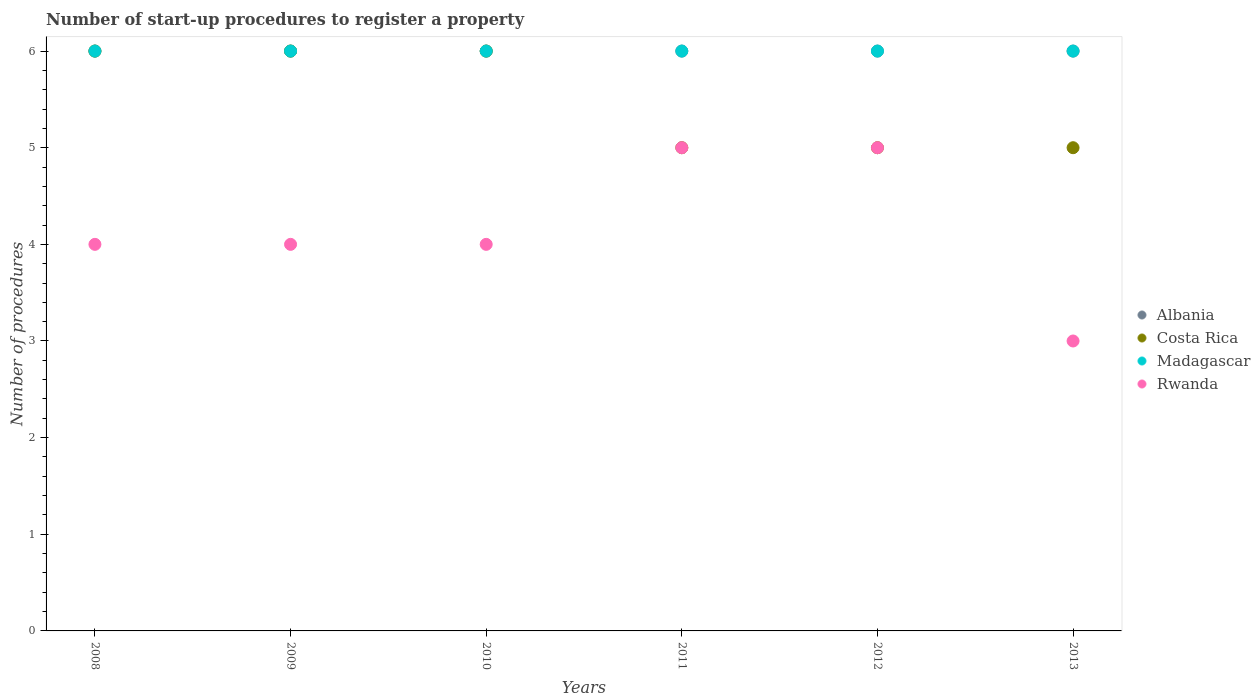How many different coloured dotlines are there?
Keep it short and to the point. 4. What is the number of procedures required to register a property in Rwanda in 2013?
Give a very brief answer. 3. Across all years, what is the maximum number of procedures required to register a property in Rwanda?
Your answer should be compact. 5. Across all years, what is the minimum number of procedures required to register a property in Rwanda?
Ensure brevity in your answer.  3. In which year was the number of procedures required to register a property in Madagascar maximum?
Offer a very short reply. 2008. In which year was the number of procedures required to register a property in Madagascar minimum?
Ensure brevity in your answer.  2008. What is the total number of procedures required to register a property in Rwanda in the graph?
Keep it short and to the point. 25. What is the difference between the number of procedures required to register a property in Costa Rica in 2010 and that in 2013?
Keep it short and to the point. 1. What is the difference between the number of procedures required to register a property in Rwanda in 2010 and the number of procedures required to register a property in Madagascar in 2012?
Provide a short and direct response. -2. In the year 2010, what is the difference between the number of procedures required to register a property in Costa Rica and number of procedures required to register a property in Albania?
Ensure brevity in your answer.  0. What is the ratio of the number of procedures required to register a property in Albania in 2011 to that in 2013?
Your answer should be very brief. 1. Is the number of procedures required to register a property in Rwanda in 2010 less than that in 2011?
Give a very brief answer. Yes. Is the sum of the number of procedures required to register a property in Madagascar in 2011 and 2012 greater than the maximum number of procedures required to register a property in Albania across all years?
Keep it short and to the point. Yes. Is it the case that in every year, the sum of the number of procedures required to register a property in Albania and number of procedures required to register a property in Rwanda  is greater than the sum of number of procedures required to register a property in Costa Rica and number of procedures required to register a property in Madagascar?
Ensure brevity in your answer.  No. Is it the case that in every year, the sum of the number of procedures required to register a property in Costa Rica and number of procedures required to register a property in Rwanda  is greater than the number of procedures required to register a property in Albania?
Make the answer very short. Yes. Does the number of procedures required to register a property in Madagascar monotonically increase over the years?
Keep it short and to the point. No. What is the difference between two consecutive major ticks on the Y-axis?
Provide a succinct answer. 1. Are the values on the major ticks of Y-axis written in scientific E-notation?
Your answer should be very brief. No. Does the graph contain any zero values?
Your answer should be very brief. No. Does the graph contain grids?
Provide a succinct answer. No. How many legend labels are there?
Your answer should be compact. 4. How are the legend labels stacked?
Make the answer very short. Vertical. What is the title of the graph?
Your answer should be compact. Number of start-up procedures to register a property. What is the label or title of the Y-axis?
Give a very brief answer. Number of procedures. What is the Number of procedures in Albania in 2008?
Make the answer very short. 6. What is the Number of procedures of Costa Rica in 2008?
Your response must be concise. 6. What is the Number of procedures of Madagascar in 2008?
Offer a very short reply. 6. What is the Number of procedures in Rwanda in 2009?
Give a very brief answer. 4. What is the Number of procedures of Albania in 2010?
Provide a short and direct response. 6. What is the Number of procedures of Costa Rica in 2010?
Your answer should be very brief. 6. What is the Number of procedures of Rwanda in 2010?
Make the answer very short. 4. What is the Number of procedures of Madagascar in 2011?
Keep it short and to the point. 6. What is the Number of procedures of Albania in 2012?
Provide a short and direct response. 6. What is the Number of procedures in Costa Rica in 2012?
Offer a very short reply. 5. What is the Number of procedures in Madagascar in 2012?
Keep it short and to the point. 6. Across all years, what is the maximum Number of procedures of Costa Rica?
Provide a short and direct response. 6. Across all years, what is the maximum Number of procedures in Rwanda?
Give a very brief answer. 5. Across all years, what is the minimum Number of procedures in Madagascar?
Offer a terse response. 6. What is the total Number of procedures of Rwanda in the graph?
Offer a terse response. 25. What is the difference between the Number of procedures in Albania in 2008 and that in 2009?
Ensure brevity in your answer.  0. What is the difference between the Number of procedures in Rwanda in 2008 and that in 2009?
Your answer should be very brief. 0. What is the difference between the Number of procedures of Albania in 2008 and that in 2010?
Provide a short and direct response. 0. What is the difference between the Number of procedures of Costa Rica in 2008 and that in 2010?
Keep it short and to the point. 0. What is the difference between the Number of procedures of Madagascar in 2008 and that in 2010?
Make the answer very short. 0. What is the difference between the Number of procedures in Albania in 2008 and that in 2011?
Offer a terse response. 0. What is the difference between the Number of procedures of Costa Rica in 2008 and that in 2011?
Offer a very short reply. 1. What is the difference between the Number of procedures in Rwanda in 2008 and that in 2011?
Provide a short and direct response. -1. What is the difference between the Number of procedures in Albania in 2008 and that in 2012?
Give a very brief answer. 0. What is the difference between the Number of procedures in Madagascar in 2008 and that in 2012?
Give a very brief answer. 0. What is the difference between the Number of procedures of Costa Rica in 2008 and that in 2013?
Offer a terse response. 1. What is the difference between the Number of procedures of Madagascar in 2008 and that in 2013?
Provide a short and direct response. 0. What is the difference between the Number of procedures in Costa Rica in 2009 and that in 2010?
Offer a very short reply. 0. What is the difference between the Number of procedures of Albania in 2009 and that in 2011?
Your answer should be very brief. 0. What is the difference between the Number of procedures in Costa Rica in 2009 and that in 2011?
Offer a terse response. 1. What is the difference between the Number of procedures of Albania in 2009 and that in 2012?
Make the answer very short. 0. What is the difference between the Number of procedures of Costa Rica in 2009 and that in 2012?
Your answer should be compact. 1. What is the difference between the Number of procedures in Rwanda in 2009 and that in 2012?
Your answer should be very brief. -1. What is the difference between the Number of procedures in Albania in 2009 and that in 2013?
Provide a succinct answer. 0. What is the difference between the Number of procedures of Costa Rica in 2009 and that in 2013?
Offer a terse response. 1. What is the difference between the Number of procedures in Albania in 2010 and that in 2011?
Offer a terse response. 0. What is the difference between the Number of procedures of Madagascar in 2010 and that in 2011?
Provide a succinct answer. 0. What is the difference between the Number of procedures in Albania in 2010 and that in 2012?
Ensure brevity in your answer.  0. What is the difference between the Number of procedures in Costa Rica in 2010 and that in 2012?
Keep it short and to the point. 1. What is the difference between the Number of procedures in Madagascar in 2010 and that in 2012?
Keep it short and to the point. 0. What is the difference between the Number of procedures of Costa Rica in 2010 and that in 2013?
Give a very brief answer. 1. What is the difference between the Number of procedures of Albania in 2011 and that in 2012?
Give a very brief answer. 0. What is the difference between the Number of procedures in Madagascar in 2011 and that in 2012?
Your answer should be compact. 0. What is the difference between the Number of procedures of Albania in 2011 and that in 2013?
Your answer should be compact. 0. What is the difference between the Number of procedures of Costa Rica in 2011 and that in 2013?
Make the answer very short. 0. What is the difference between the Number of procedures of Albania in 2012 and that in 2013?
Your response must be concise. 0. What is the difference between the Number of procedures in Rwanda in 2012 and that in 2013?
Offer a terse response. 2. What is the difference between the Number of procedures in Albania in 2008 and the Number of procedures in Costa Rica in 2009?
Provide a succinct answer. 0. What is the difference between the Number of procedures in Albania in 2008 and the Number of procedures in Madagascar in 2009?
Your response must be concise. 0. What is the difference between the Number of procedures in Albania in 2008 and the Number of procedures in Rwanda in 2009?
Offer a very short reply. 2. What is the difference between the Number of procedures in Costa Rica in 2008 and the Number of procedures in Madagascar in 2009?
Your answer should be very brief. 0. What is the difference between the Number of procedures in Madagascar in 2008 and the Number of procedures in Rwanda in 2009?
Your answer should be very brief. 2. What is the difference between the Number of procedures of Albania in 2008 and the Number of procedures of Costa Rica in 2010?
Your answer should be very brief. 0. What is the difference between the Number of procedures in Albania in 2008 and the Number of procedures in Rwanda in 2010?
Your response must be concise. 2. What is the difference between the Number of procedures of Costa Rica in 2008 and the Number of procedures of Rwanda in 2010?
Make the answer very short. 2. What is the difference between the Number of procedures of Madagascar in 2008 and the Number of procedures of Rwanda in 2010?
Ensure brevity in your answer.  2. What is the difference between the Number of procedures of Albania in 2008 and the Number of procedures of Madagascar in 2011?
Your response must be concise. 0. What is the difference between the Number of procedures of Costa Rica in 2008 and the Number of procedures of Madagascar in 2011?
Provide a succinct answer. 0. What is the difference between the Number of procedures of Costa Rica in 2008 and the Number of procedures of Rwanda in 2011?
Provide a short and direct response. 1. What is the difference between the Number of procedures of Madagascar in 2008 and the Number of procedures of Rwanda in 2011?
Provide a short and direct response. 1. What is the difference between the Number of procedures of Albania in 2008 and the Number of procedures of Costa Rica in 2012?
Offer a terse response. 1. What is the difference between the Number of procedures of Albania in 2008 and the Number of procedures of Madagascar in 2012?
Your answer should be very brief. 0. What is the difference between the Number of procedures of Albania in 2009 and the Number of procedures of Costa Rica in 2010?
Offer a terse response. 0. What is the difference between the Number of procedures of Costa Rica in 2009 and the Number of procedures of Madagascar in 2010?
Provide a short and direct response. 0. What is the difference between the Number of procedures in Madagascar in 2009 and the Number of procedures in Rwanda in 2010?
Your answer should be compact. 2. What is the difference between the Number of procedures in Albania in 2009 and the Number of procedures in Costa Rica in 2011?
Provide a succinct answer. 1. What is the difference between the Number of procedures in Albania in 2009 and the Number of procedures in Rwanda in 2011?
Your answer should be compact. 1. What is the difference between the Number of procedures in Costa Rica in 2009 and the Number of procedures in Madagascar in 2011?
Offer a very short reply. 0. What is the difference between the Number of procedures in Costa Rica in 2009 and the Number of procedures in Rwanda in 2011?
Provide a succinct answer. 1. What is the difference between the Number of procedures of Albania in 2009 and the Number of procedures of Costa Rica in 2012?
Ensure brevity in your answer.  1. What is the difference between the Number of procedures in Costa Rica in 2009 and the Number of procedures in Rwanda in 2012?
Offer a very short reply. 1. What is the difference between the Number of procedures in Albania in 2009 and the Number of procedures in Madagascar in 2013?
Your answer should be very brief. 0. What is the difference between the Number of procedures of Costa Rica in 2009 and the Number of procedures of Rwanda in 2013?
Offer a terse response. 3. What is the difference between the Number of procedures of Albania in 2010 and the Number of procedures of Costa Rica in 2011?
Ensure brevity in your answer.  1. What is the difference between the Number of procedures of Albania in 2010 and the Number of procedures of Rwanda in 2011?
Keep it short and to the point. 1. What is the difference between the Number of procedures in Costa Rica in 2010 and the Number of procedures in Rwanda in 2011?
Your answer should be very brief. 1. What is the difference between the Number of procedures in Madagascar in 2010 and the Number of procedures in Rwanda in 2011?
Your answer should be very brief. 1. What is the difference between the Number of procedures in Albania in 2010 and the Number of procedures in Costa Rica in 2012?
Your response must be concise. 1. What is the difference between the Number of procedures of Albania in 2010 and the Number of procedures of Madagascar in 2012?
Offer a terse response. 0. What is the difference between the Number of procedures of Costa Rica in 2010 and the Number of procedures of Madagascar in 2012?
Keep it short and to the point. 0. What is the difference between the Number of procedures in Madagascar in 2010 and the Number of procedures in Rwanda in 2012?
Your response must be concise. 1. What is the difference between the Number of procedures in Albania in 2010 and the Number of procedures in Madagascar in 2013?
Give a very brief answer. 0. What is the difference between the Number of procedures in Madagascar in 2010 and the Number of procedures in Rwanda in 2013?
Make the answer very short. 3. What is the difference between the Number of procedures in Albania in 2011 and the Number of procedures in Costa Rica in 2012?
Offer a very short reply. 1. What is the difference between the Number of procedures in Albania in 2011 and the Number of procedures in Madagascar in 2012?
Offer a terse response. 0. What is the difference between the Number of procedures of Albania in 2011 and the Number of procedures of Rwanda in 2012?
Provide a succinct answer. 1. What is the difference between the Number of procedures of Costa Rica in 2011 and the Number of procedures of Madagascar in 2012?
Ensure brevity in your answer.  -1. What is the difference between the Number of procedures in Madagascar in 2011 and the Number of procedures in Rwanda in 2012?
Keep it short and to the point. 1. What is the difference between the Number of procedures of Albania in 2011 and the Number of procedures of Madagascar in 2013?
Provide a succinct answer. 0. What is the difference between the Number of procedures in Costa Rica in 2011 and the Number of procedures in Madagascar in 2013?
Provide a short and direct response. -1. What is the difference between the Number of procedures of Costa Rica in 2012 and the Number of procedures of Rwanda in 2013?
Your answer should be very brief. 2. What is the difference between the Number of procedures in Madagascar in 2012 and the Number of procedures in Rwanda in 2013?
Your response must be concise. 3. What is the average Number of procedures of Costa Rica per year?
Give a very brief answer. 5.5. What is the average Number of procedures of Madagascar per year?
Your answer should be very brief. 6. What is the average Number of procedures of Rwanda per year?
Provide a succinct answer. 4.17. In the year 2008, what is the difference between the Number of procedures in Albania and Number of procedures in Rwanda?
Provide a succinct answer. 2. In the year 2009, what is the difference between the Number of procedures of Albania and Number of procedures of Rwanda?
Provide a succinct answer. 2. In the year 2009, what is the difference between the Number of procedures in Costa Rica and Number of procedures in Madagascar?
Provide a short and direct response. 0. In the year 2010, what is the difference between the Number of procedures in Albania and Number of procedures in Madagascar?
Your answer should be very brief. 0. In the year 2010, what is the difference between the Number of procedures in Costa Rica and Number of procedures in Rwanda?
Make the answer very short. 2. In the year 2011, what is the difference between the Number of procedures in Albania and Number of procedures in Costa Rica?
Your answer should be very brief. 1. In the year 2011, what is the difference between the Number of procedures of Albania and Number of procedures of Rwanda?
Offer a terse response. 1. In the year 2012, what is the difference between the Number of procedures in Albania and Number of procedures in Costa Rica?
Make the answer very short. 1. In the year 2012, what is the difference between the Number of procedures in Costa Rica and Number of procedures in Madagascar?
Your response must be concise. -1. In the year 2013, what is the difference between the Number of procedures of Albania and Number of procedures of Rwanda?
Your answer should be compact. 3. In the year 2013, what is the difference between the Number of procedures of Costa Rica and Number of procedures of Madagascar?
Your response must be concise. -1. In the year 2013, what is the difference between the Number of procedures of Costa Rica and Number of procedures of Rwanda?
Your answer should be compact. 2. In the year 2013, what is the difference between the Number of procedures in Madagascar and Number of procedures in Rwanda?
Make the answer very short. 3. What is the ratio of the Number of procedures in Costa Rica in 2008 to that in 2009?
Keep it short and to the point. 1. What is the ratio of the Number of procedures in Madagascar in 2008 to that in 2009?
Provide a short and direct response. 1. What is the ratio of the Number of procedures in Rwanda in 2008 to that in 2009?
Offer a very short reply. 1. What is the ratio of the Number of procedures in Costa Rica in 2008 to that in 2010?
Ensure brevity in your answer.  1. What is the ratio of the Number of procedures in Madagascar in 2008 to that in 2010?
Your response must be concise. 1. What is the ratio of the Number of procedures in Albania in 2008 to that in 2011?
Provide a succinct answer. 1. What is the ratio of the Number of procedures of Rwanda in 2008 to that in 2011?
Ensure brevity in your answer.  0.8. What is the ratio of the Number of procedures in Albania in 2008 to that in 2012?
Your answer should be very brief. 1. What is the ratio of the Number of procedures of Costa Rica in 2008 to that in 2012?
Make the answer very short. 1.2. What is the ratio of the Number of procedures in Madagascar in 2008 to that in 2012?
Provide a succinct answer. 1. What is the ratio of the Number of procedures of Albania in 2008 to that in 2013?
Make the answer very short. 1. What is the ratio of the Number of procedures of Costa Rica in 2008 to that in 2013?
Provide a short and direct response. 1.2. What is the ratio of the Number of procedures in Albania in 2009 to that in 2010?
Provide a succinct answer. 1. What is the ratio of the Number of procedures in Madagascar in 2009 to that in 2010?
Make the answer very short. 1. What is the ratio of the Number of procedures in Madagascar in 2009 to that in 2011?
Provide a succinct answer. 1. What is the ratio of the Number of procedures of Rwanda in 2009 to that in 2011?
Provide a short and direct response. 0.8. What is the ratio of the Number of procedures in Albania in 2009 to that in 2012?
Your response must be concise. 1. What is the ratio of the Number of procedures of Madagascar in 2009 to that in 2012?
Offer a terse response. 1. What is the ratio of the Number of procedures in Rwanda in 2009 to that in 2012?
Your answer should be very brief. 0.8. What is the ratio of the Number of procedures in Albania in 2009 to that in 2013?
Provide a succinct answer. 1. What is the ratio of the Number of procedures in Rwanda in 2009 to that in 2013?
Provide a short and direct response. 1.33. What is the ratio of the Number of procedures in Rwanda in 2010 to that in 2012?
Provide a short and direct response. 0.8. What is the ratio of the Number of procedures in Albania in 2010 to that in 2013?
Provide a short and direct response. 1. What is the ratio of the Number of procedures of Madagascar in 2010 to that in 2013?
Your response must be concise. 1. What is the ratio of the Number of procedures of Costa Rica in 2011 to that in 2012?
Your answer should be very brief. 1. What is the ratio of the Number of procedures in Costa Rica in 2011 to that in 2013?
Your answer should be compact. 1. What is the ratio of the Number of procedures of Rwanda in 2011 to that in 2013?
Provide a succinct answer. 1.67. What is the ratio of the Number of procedures in Albania in 2012 to that in 2013?
Keep it short and to the point. 1. What is the difference between the highest and the second highest Number of procedures of Albania?
Give a very brief answer. 0. What is the difference between the highest and the second highest Number of procedures of Rwanda?
Your answer should be compact. 0. What is the difference between the highest and the lowest Number of procedures of Albania?
Provide a succinct answer. 0. What is the difference between the highest and the lowest Number of procedures in Rwanda?
Your response must be concise. 2. 